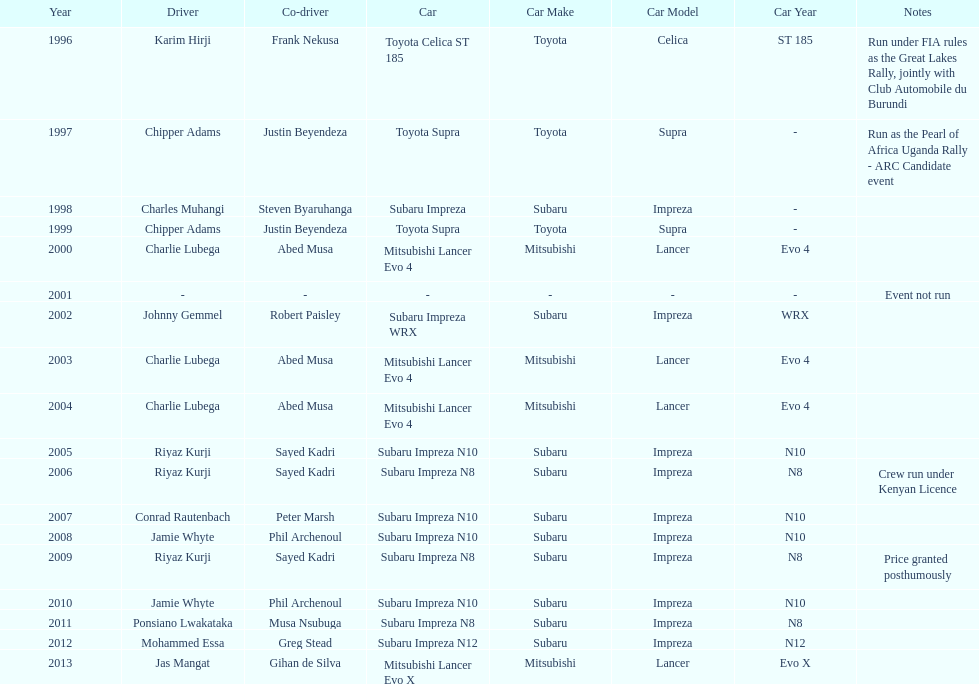Which was the only year that the event was not run? 2001. 